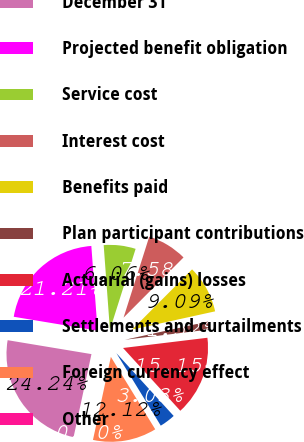<chart> <loc_0><loc_0><loc_500><loc_500><pie_chart><fcel>December 31<fcel>Projected benefit obligation<fcel>Service cost<fcel>Interest cost<fcel>Benefits paid<fcel>Plan participant contributions<fcel>Actuarial (gains) losses<fcel>Settlements and curtailments<fcel>Foreign currency effect<fcel>Other<nl><fcel>24.24%<fcel>21.21%<fcel>6.06%<fcel>7.58%<fcel>9.09%<fcel>1.52%<fcel>15.15%<fcel>3.03%<fcel>12.12%<fcel>0.0%<nl></chart> 